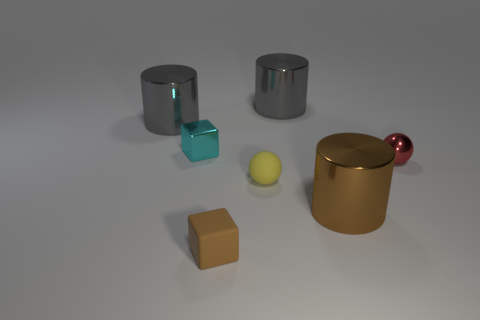Add 2 gray metal cylinders. How many objects exist? 9 Subtract all cylinders. How many objects are left? 4 Add 2 large red cubes. How many large red cubes exist? 2 Subtract 0 blue spheres. How many objects are left? 7 Subtract all tiny cyan metallic blocks. Subtract all small red spheres. How many objects are left? 5 Add 3 large gray objects. How many large gray objects are left? 5 